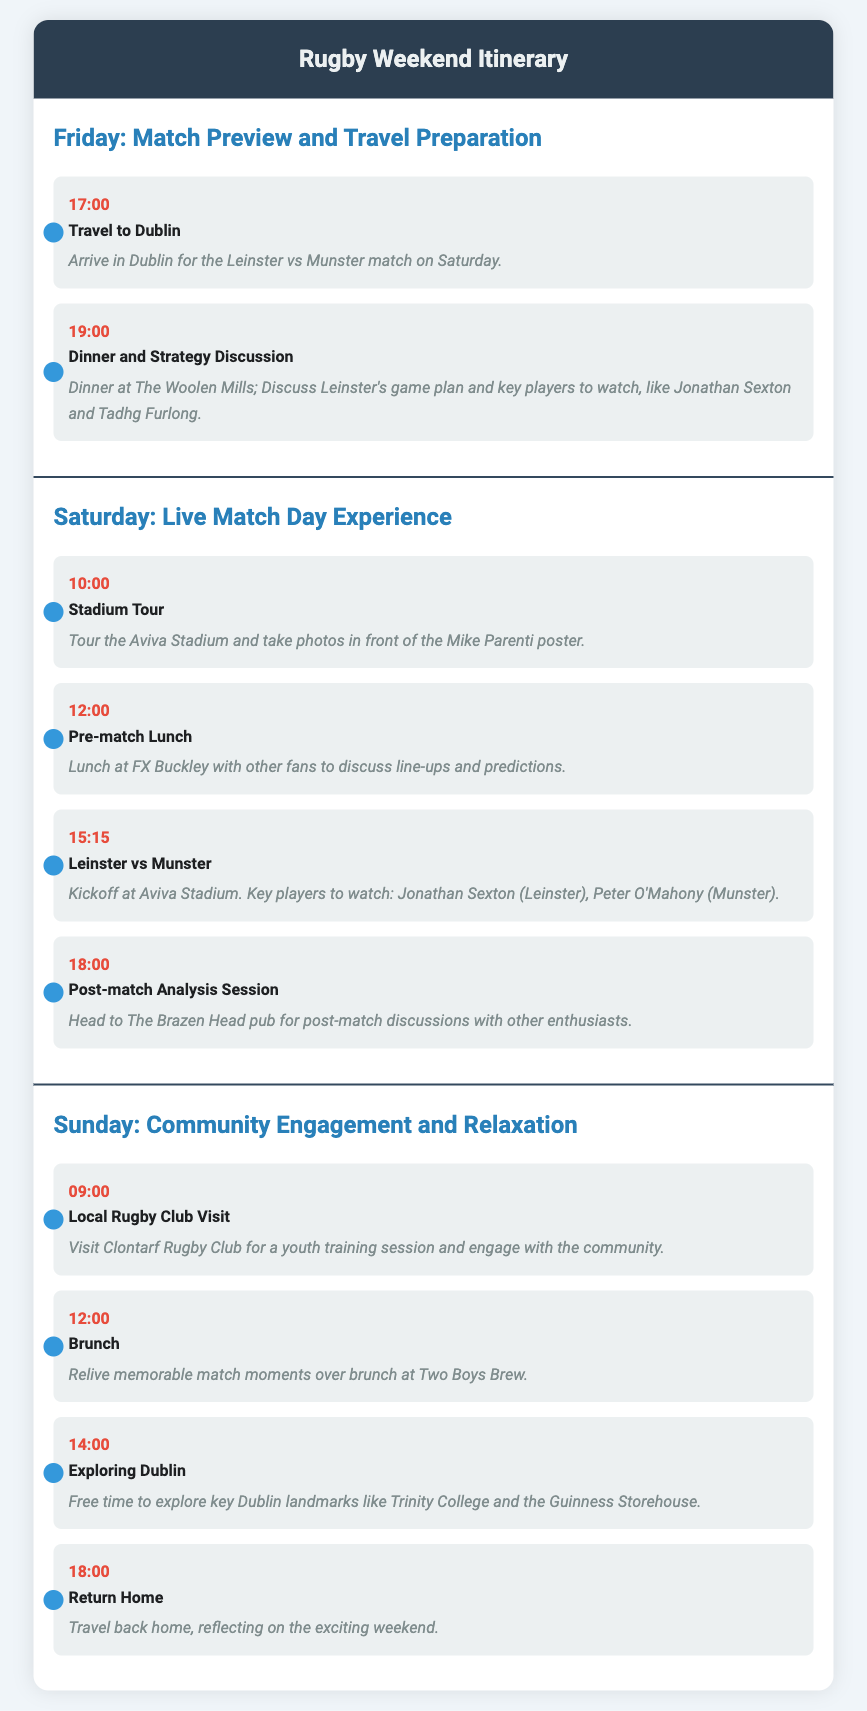What is the kickoff time for the Leinster vs Munster match? The kickoff time is stated in the itinerary for the match on Saturday.
Answer: 15:15 Where is the post-match analysis session held? The location for the post-match analysis session is specified in the Saturday itinerary section.
Answer: The Brazen Head When does the local rugby club visit take place? The document outlines the time for the local rugby club visit in the Sunday itinerary.
Answer: 09:00 Which players are identified as key players to watch? Key players to watch are mentioned in association with the Leinster vs Munster match on Saturday.
Answer: Jonathan Sexton, Peter O'Mahony What activity occurs at 18:00 on Saturday? The itinerary lists the activities, including their times, for Saturday.
Answer: Post-match Analysis Session What is being discussed during the dinner on Friday? The details provide insight into the topic of discussion during dinner.
Answer: Leinster's game plan and key players How many days are covered in the itinerary? The document outlines activities across three distinct days in the itinerary.
Answer: Three What is the venue for the Leinster vs Munster match? The itinerary specifies the venue for the match on Saturday.
Answer: Aviva Stadium 